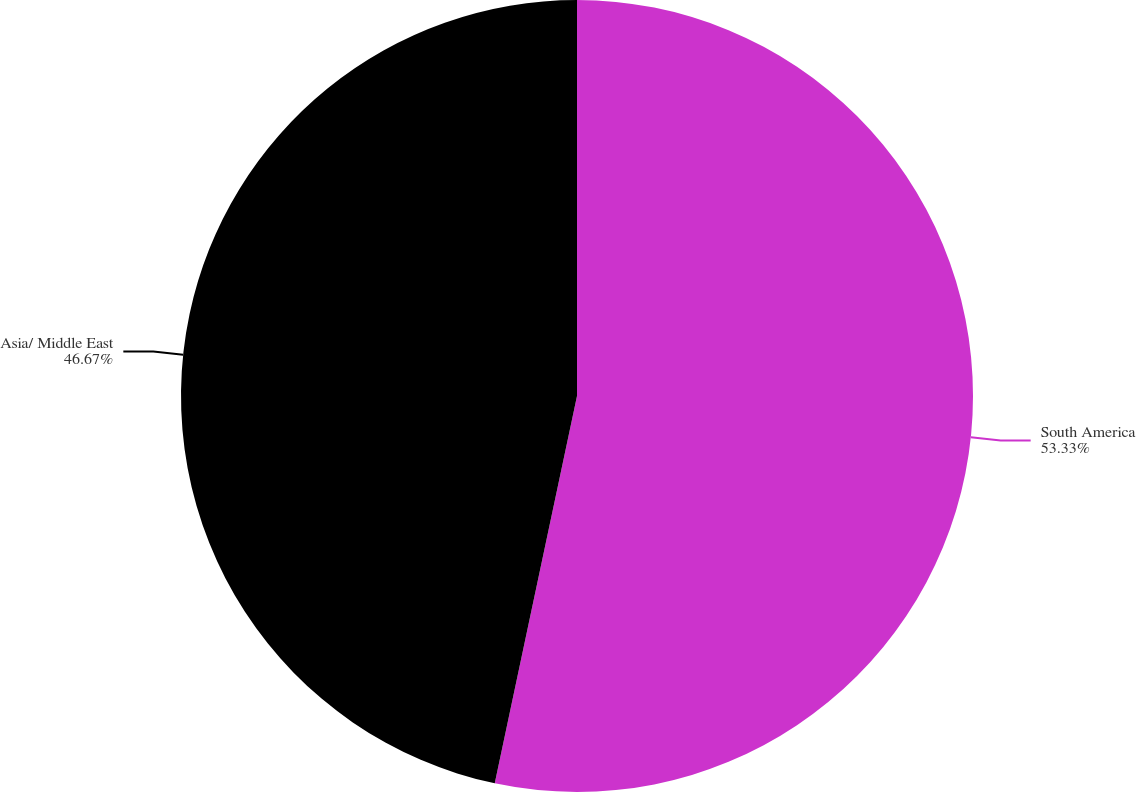Convert chart. <chart><loc_0><loc_0><loc_500><loc_500><pie_chart><fcel>South America<fcel>Asia/ Middle East<nl><fcel>53.33%<fcel>46.67%<nl></chart> 